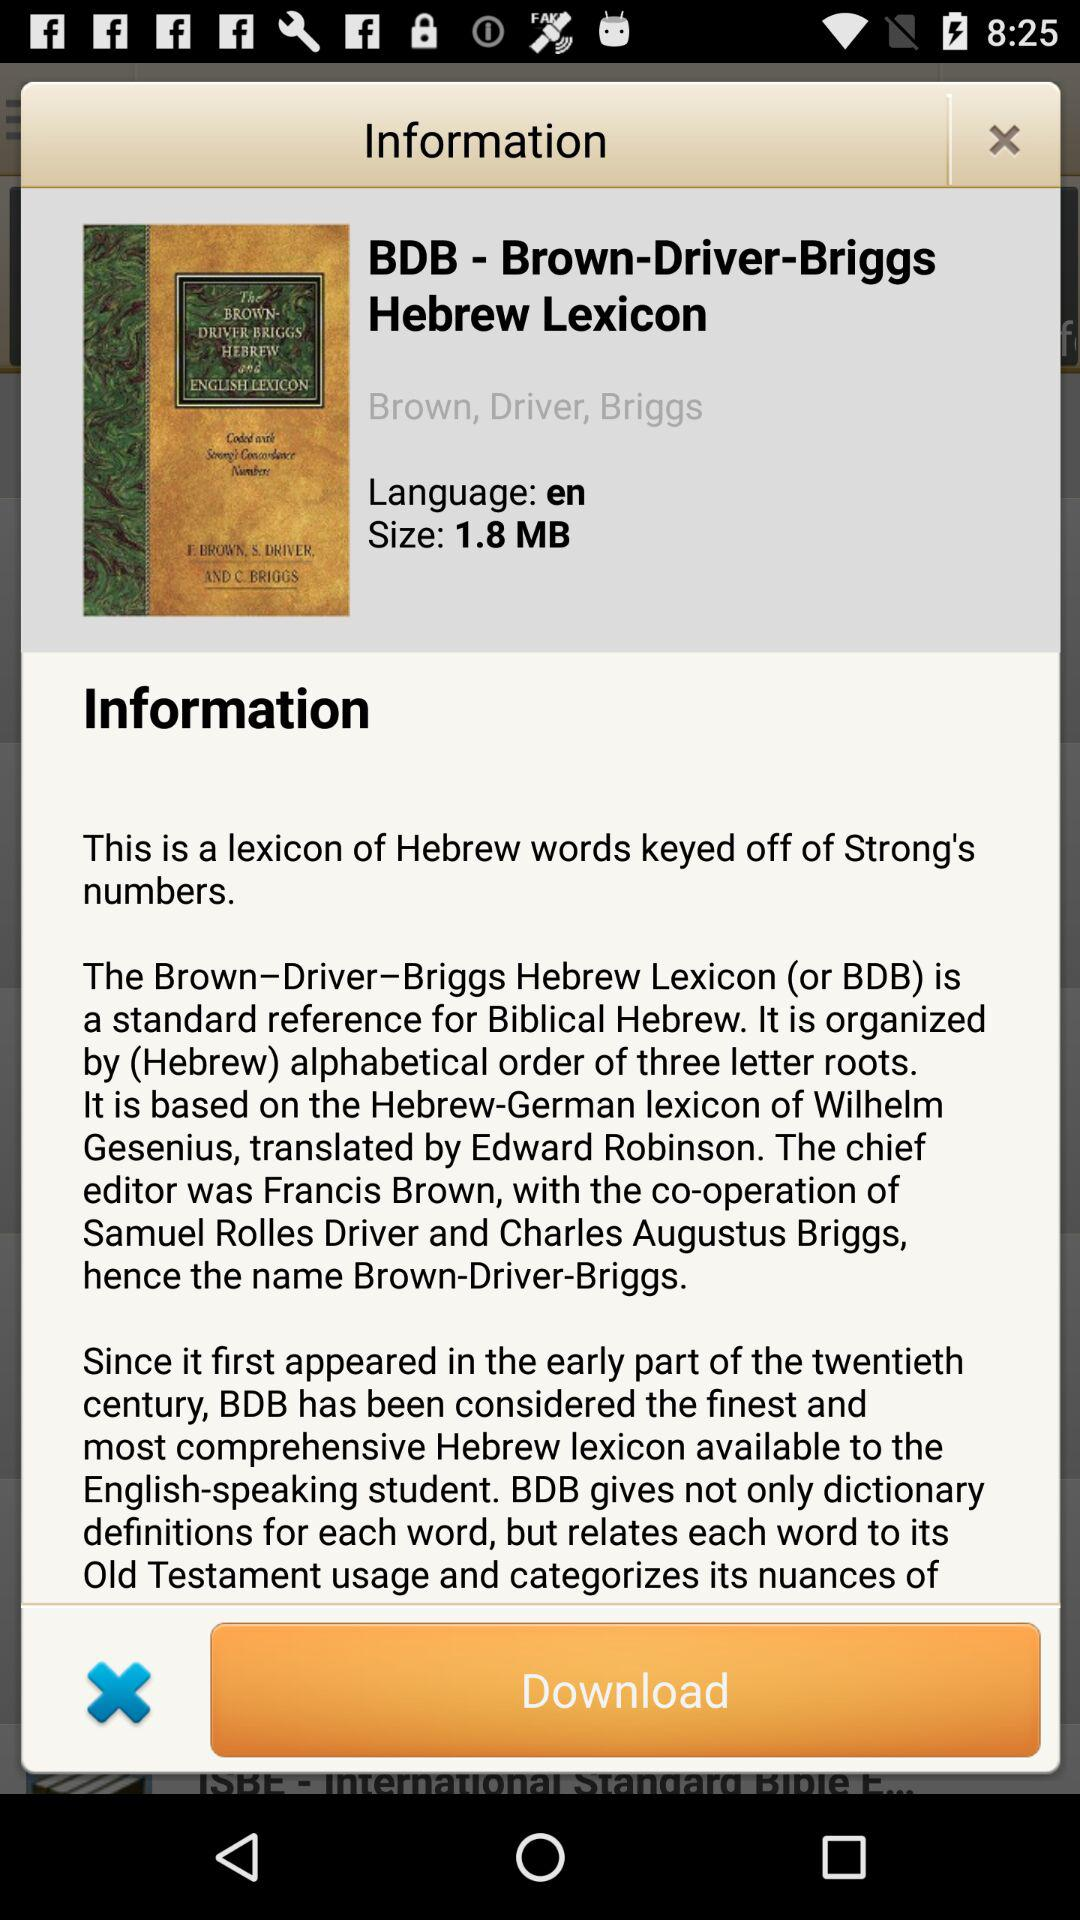What is the language of BDB - Brown-Driver-Briggs Hebrew Lexicon? The language is English. 